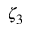<formula> <loc_0><loc_0><loc_500><loc_500>\zeta _ { 3 }</formula> 